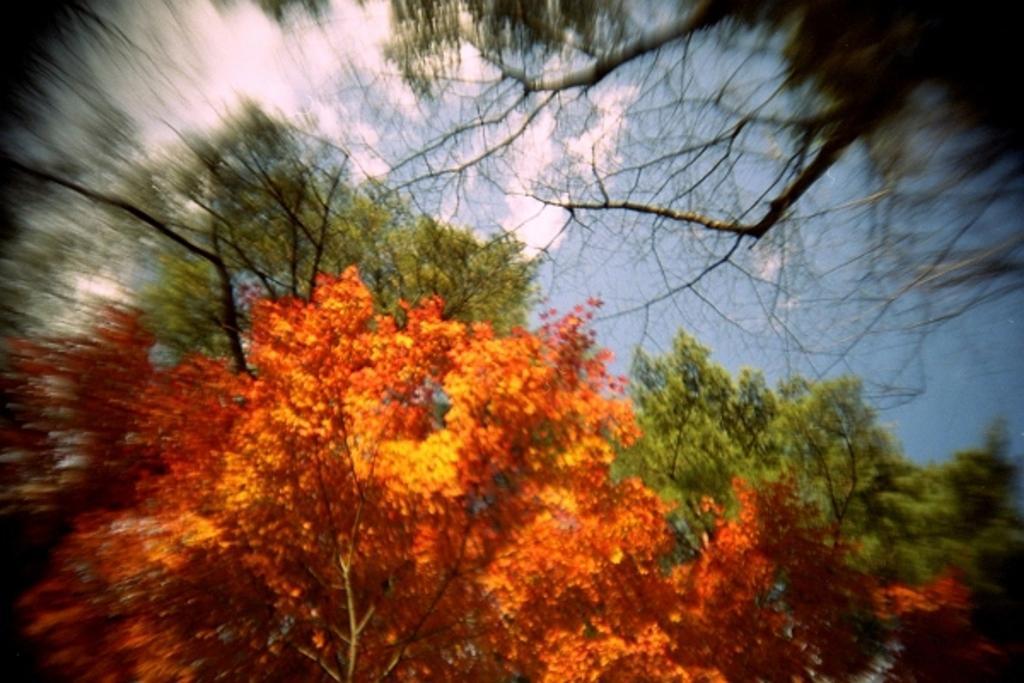Please provide a concise description of this image. This picture contains trees. At the edges it is clear. Sky is clear and it is sunny. 